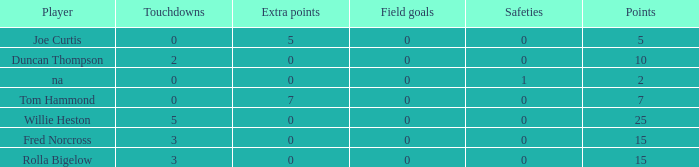Can you parse all the data within this table? {'header': ['Player', 'Touchdowns', 'Extra points', 'Field goals', 'Safeties', 'Points'], 'rows': [['Joe Curtis', '0', '5', '0', '0', '5'], ['Duncan Thompson', '2', '0', '0', '0', '10'], ['na', '0', '0', '0', '1', '2'], ['Tom Hammond', '0', '7', '0', '0', '7'], ['Willie Heston', '5', '0', '0', '0', '25'], ['Fred Norcross', '3', '0', '0', '0', '15'], ['Rolla Bigelow', '3', '0', '0', '0', '15']]} Which Points is the lowest one that has Touchdowns smaller than 2, and an Extra points of 7, and a Field goals smaller than 0? None. 